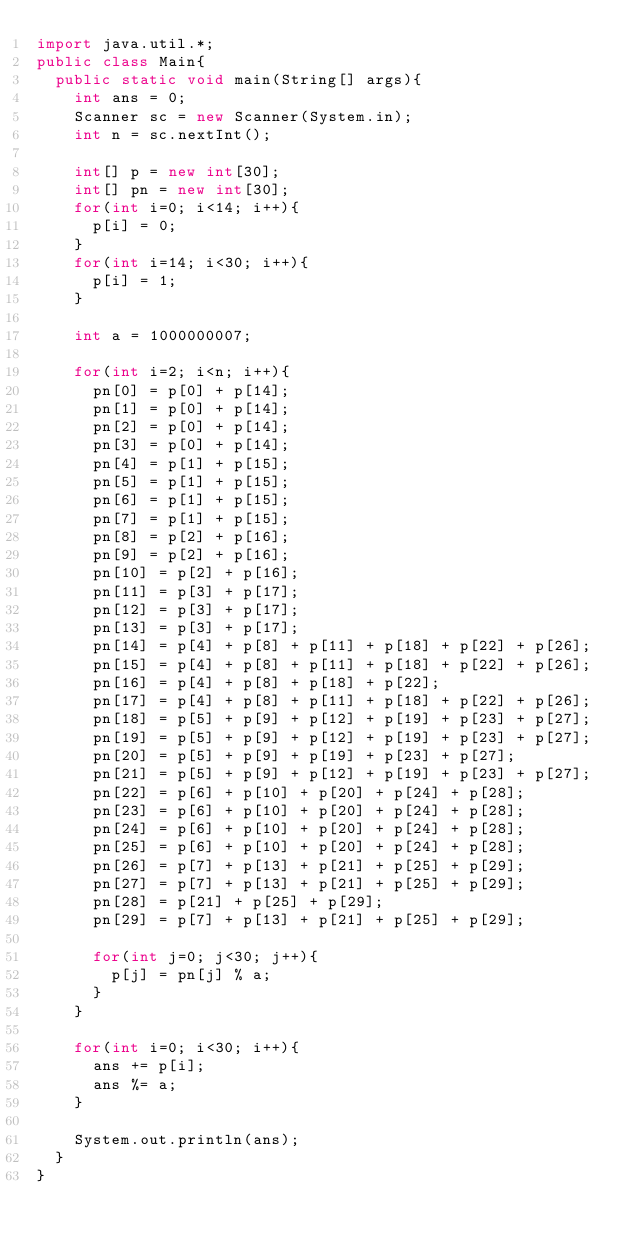<code> <loc_0><loc_0><loc_500><loc_500><_Java_>import java.util.*;
public class Main{
	public static void main(String[] args){
		int ans = 0;
		Scanner sc = new Scanner(System.in);
		int n = sc.nextInt();
		
		int[] p = new int[30];
		int[] pn = new int[30];
		for(int i=0; i<14; i++){
			p[i] = 0;
		}
		for(int i=14; i<30; i++){
			p[i] = 1;
		}
		
		int a = 1000000007;
		
		for(int i=2; i<n; i++){
			pn[0] = p[0] + p[14];
			pn[1] = p[0] + p[14];
			pn[2] = p[0] + p[14];
			pn[3] = p[0] + p[14];
			pn[4] = p[1] + p[15];
			pn[5] = p[1] + p[15];
			pn[6] = p[1] + p[15];
			pn[7] = p[1] + p[15];
			pn[8] = p[2] + p[16];
			pn[9] = p[2] + p[16];
			pn[10] = p[2] + p[16];
			pn[11] = p[3] + p[17];
			pn[12] = p[3] + p[17];
			pn[13] = p[3] + p[17];
			pn[14] = p[4] + p[8] + p[11] + p[18] + p[22] + p[26];
			pn[15] = p[4] + p[8] + p[11] + p[18] + p[22] + p[26];
			pn[16] = p[4] + p[8] + p[18] + p[22];
			pn[17] = p[4] + p[8] + p[11] + p[18] + p[22] + p[26];
			pn[18] = p[5] + p[9] + p[12] + p[19] + p[23] + p[27];
			pn[19] = p[5] + p[9] + p[12] + p[19] + p[23] + p[27];
			pn[20] = p[5] + p[9] + p[19] + p[23] + p[27];
			pn[21] = p[5] + p[9] + p[12] + p[19] + p[23] + p[27];
			pn[22] = p[6] + p[10] + p[20] + p[24] + p[28];
			pn[23] = p[6] + p[10] + p[20] + p[24] + p[28];
			pn[24] = p[6] + p[10] + p[20] + p[24] + p[28];
			pn[25] = p[6] + p[10] + p[20] + p[24] + p[28];
			pn[26] = p[7] + p[13] + p[21] + p[25] + p[29];
			pn[27] = p[7] + p[13] + p[21] + p[25] + p[29];
			pn[28] = p[21] + p[25] + p[29];
			pn[29] = p[7] + p[13] + p[21] + p[25] + p[29];
			
			for(int j=0; j<30; j++){
				p[j] = pn[j] % a;
			}
		}
		
		for(int i=0; i<30; i++){
			ans += p[i];
			ans %= a;
		}
		
		System.out.println(ans);
	}
}
</code> 